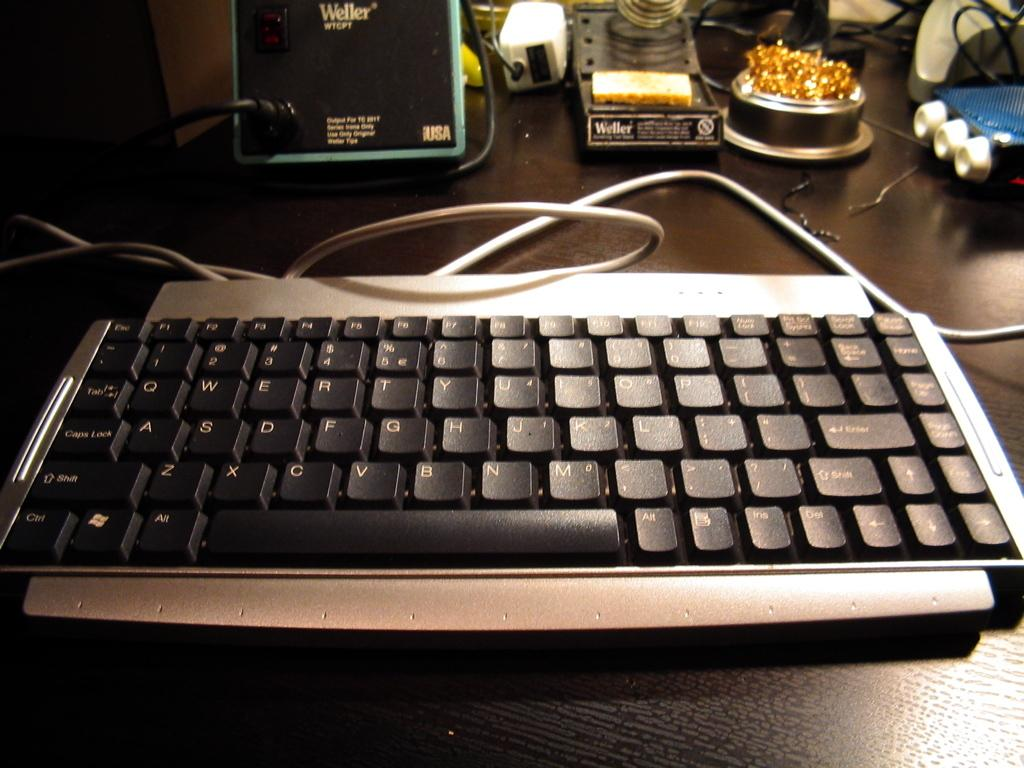<image>
Describe the image concisely. a keyboard in front of a item that says weller wtgpt  on it 